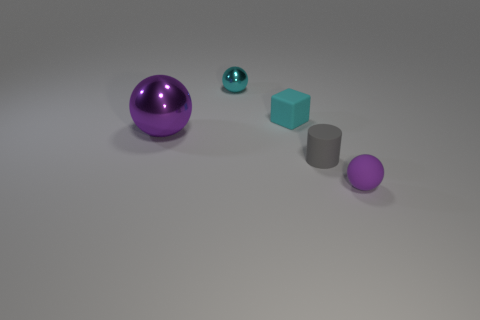Are there any other metal objects that have the same shape as the small gray object?
Your answer should be very brief. No. What is the shape of the purple object behind the purple ball that is on the right side of the cyan matte object?
Provide a succinct answer. Sphere. There is a small purple matte object; what shape is it?
Your answer should be compact. Sphere. There is a small cyan thing that is behind the matte cube to the right of the purple sphere that is behind the tiny purple matte thing; what is it made of?
Your answer should be very brief. Metal. What number of other things are there of the same material as the small gray cylinder
Offer a very short reply. 2. How many purple shiny spheres are on the right side of the sphere that is in front of the gray rubber thing?
Your answer should be compact. 0. What number of cylinders are big purple metal objects or tiny gray things?
Your answer should be very brief. 1. There is a thing that is both left of the small cube and behind the big purple object; what color is it?
Offer a very short reply. Cyan. Is there anything else that has the same color as the small rubber block?
Provide a short and direct response. Yes. There is a tiny ball left of the sphere right of the cyan matte block; what color is it?
Offer a very short reply. Cyan. 